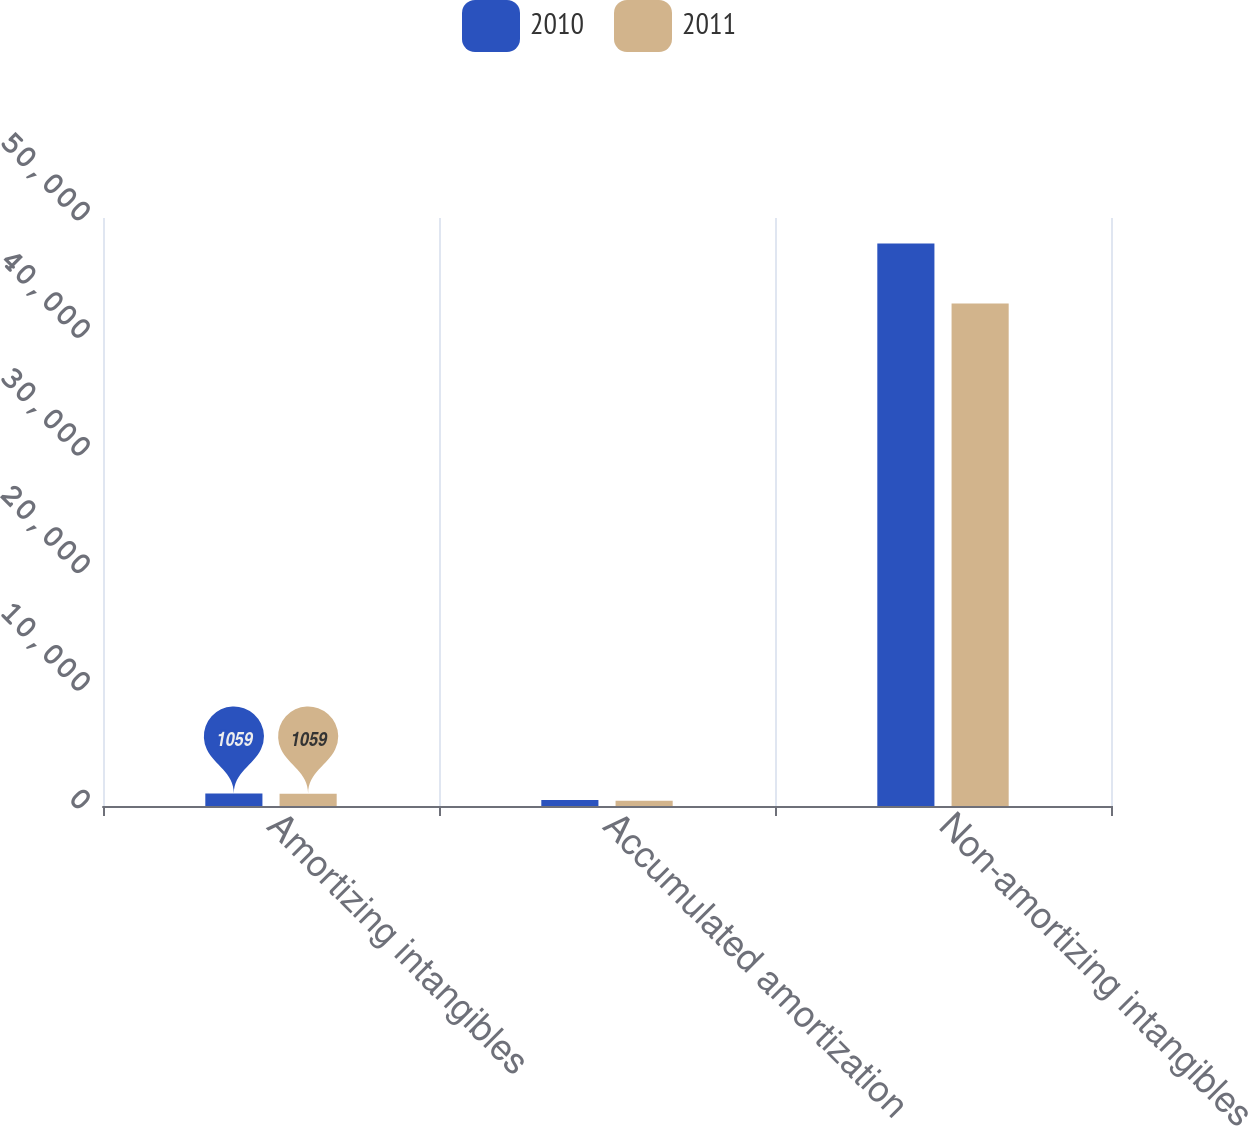Convert chart to OTSL. <chart><loc_0><loc_0><loc_500><loc_500><stacked_bar_chart><ecel><fcel>Amortizing intangibles<fcel>Accumulated amortization<fcel>Non-amortizing intangibles<nl><fcel>2010<fcel>1059<fcel>504<fcel>47841<nl><fcel>2011<fcel>1047<fcel>452<fcel>42721<nl></chart> 